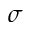<formula> <loc_0><loc_0><loc_500><loc_500>\sigma</formula> 